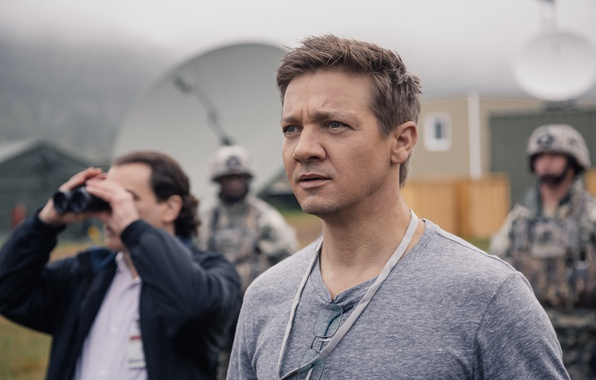What might the mood be like among the team members in this setting? The mood among the team members likely ranges from tense and focused to methodical and diligent. The nature of their tasks demands high levels of concentration and precision, fostering a professional environment where efficiency and careful coordination are paramount. Despite the inherent stress, there's also a sense of camaraderie and mutual support, as the team works closely to achieve common goals. 